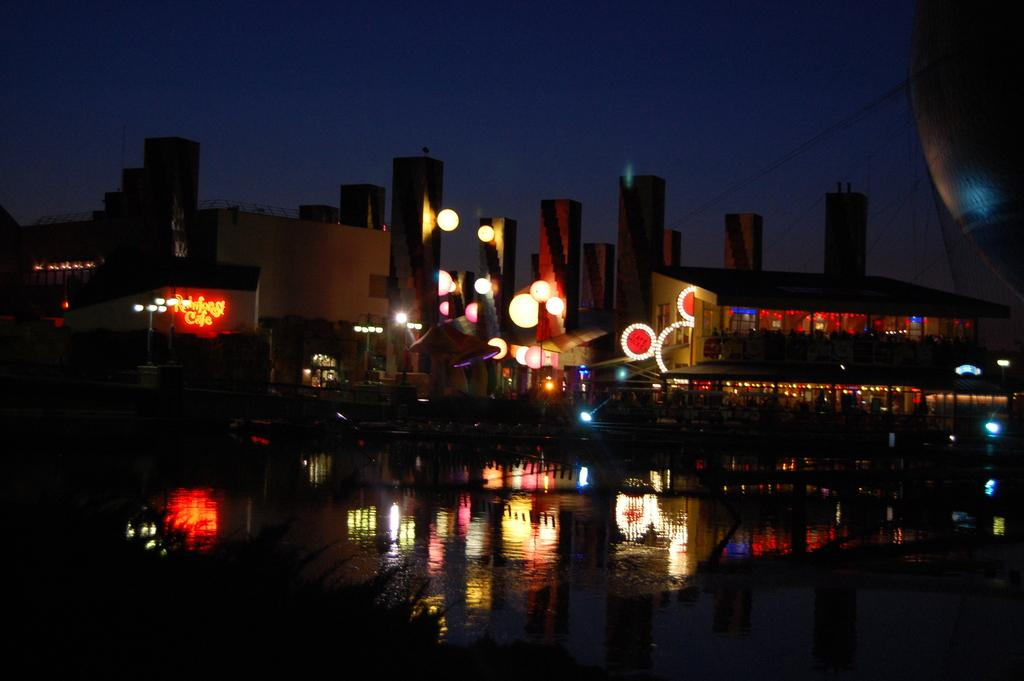What type of structures can be seen in the image? There are buildings in the image. What else is visible in the image besides the buildings? There are lights and poles in the image. What can be seen reflecting on the water in the image? There are reflections on the water in the image. What part of the natural environment is visible in the image? The sky is visible in the image. What type of thrill can be seen in the image? There is no thrill present in the image; it features buildings, lights, poles, reflections on the water, and the sky. Can you tell me how many people are crying in the image? There are no people or crying depicted in the image. 